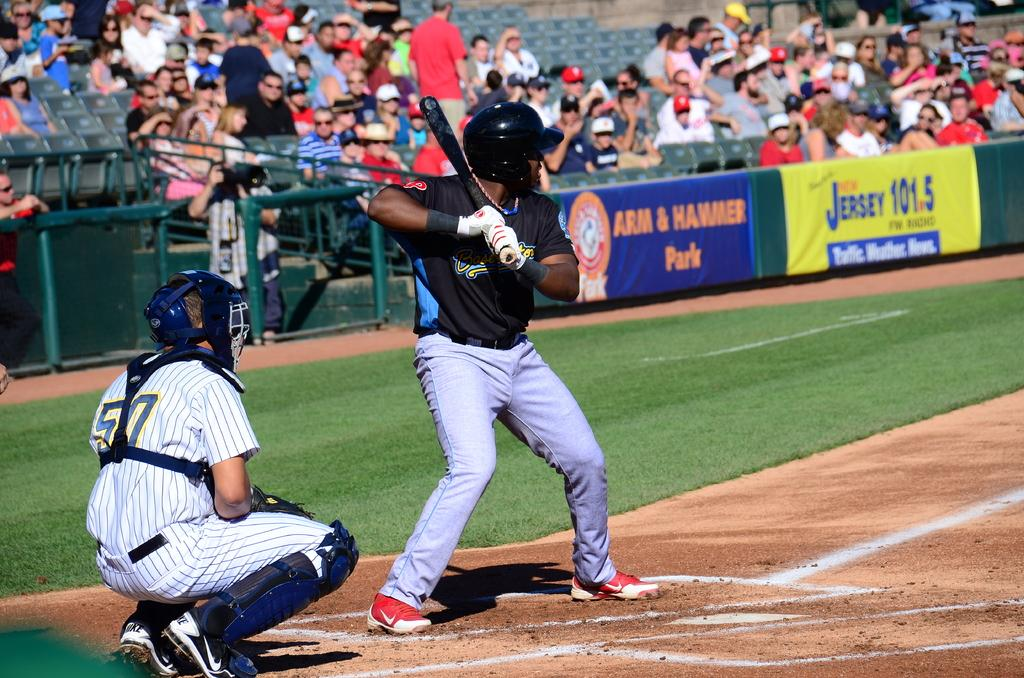<image>
Describe the image concisely. Baseball player about to bat in front of the empire wearing number 50. 